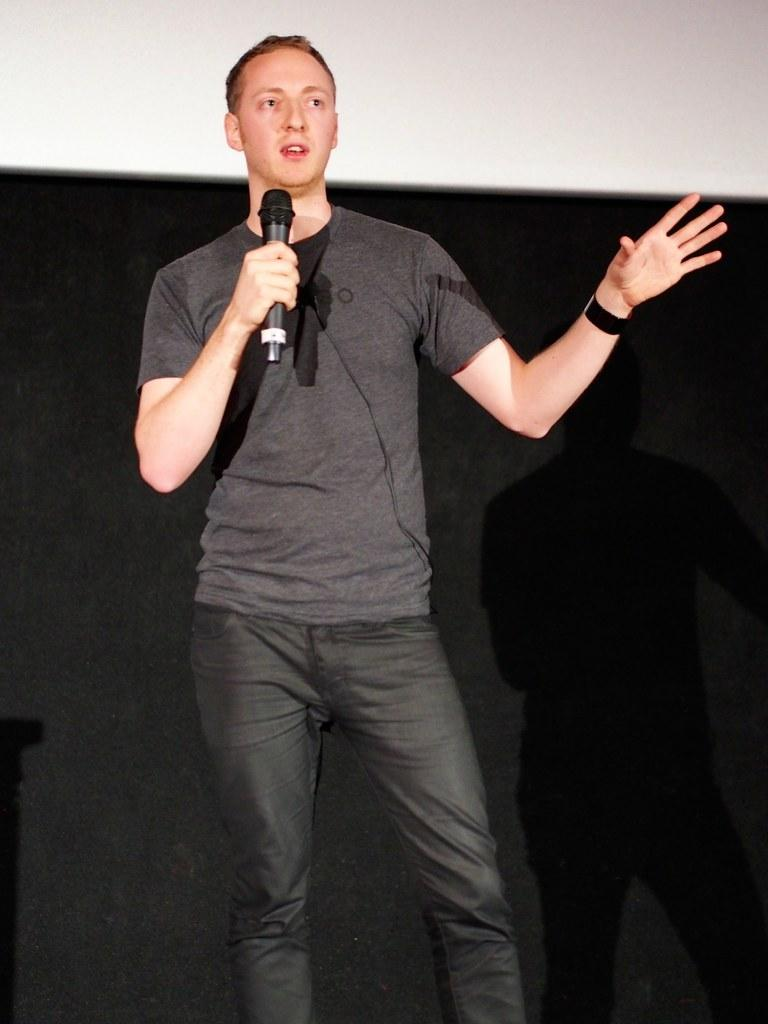What is the main subject of the image? There is a man standing in the center of the image. What is the man holding in the image? The man is holding a microphone. What can be seen in the background of the image? There is a wall visible in the background of the image. Is the man playing a guitar in the image? There is no guitar present in the image; the man is holding a microphone. 